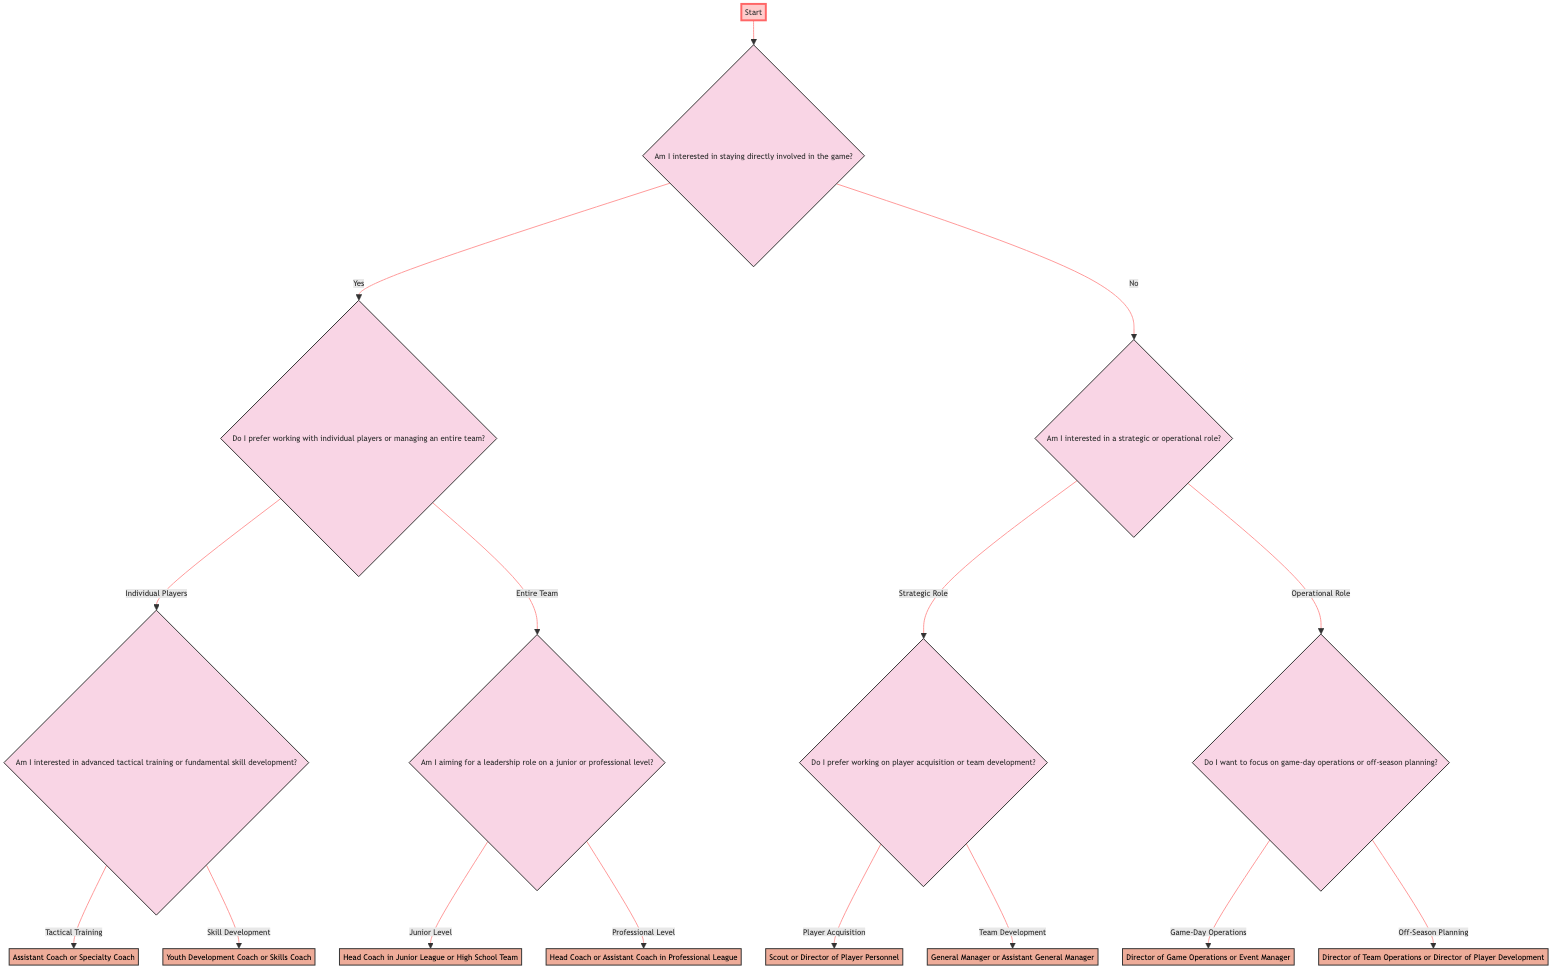What is the first question in the diagram? The first question in the diagram is found at the starting node, which is the decision about staying directly involved in the game.
Answer: Am I interested in staying directly involved in the game? How many options are there after the first question? Once the first question is asked, there are two options presented: 'Yes' or 'No'. This means there are two branches to follow based on the decision made.
Answer: 2 If the answer is "Yes", what is the next question? If the answer to the first question is "Yes", the next question is about whether the individual prefers working with individual players or managing an entire team.
Answer: Do I prefer working with individual players or managing an entire team? If I choose "Entire Team" and then "Professional Level," what should I consider pursuing? By choosing "Entire Team" and "Professional Level," the path leads directly to the decision node that suggests pursuing Head Coach or Assistant Coach in Professional League.
Answer: Head Coach or Assistant Coach in Professional League What role is suggested if the answer is "No" to staying directly involved and "Strategic Role" is chosen? If "No" is selected for staying directly involved and "Strategic Role" is chosen, the next question asks about preferences between player acquisition or team development, which leads to specific roles based on those choices.
Answer: Scout or Director of Player Personnel or General Manager or Assistant General Manager Which decision leads to a focus on off-season planning? The decision that leads to a focus on off-season planning comes from selecting "No" for staying directly involved, then selecting "Operational Role," and finally choosing "Off-Season Planning."
Answer: Director of Team Operations or Director of Player Development What is the outcome if the answer to the third question is "Tactical Training"? If "Tactical Training" is the answer to the third question about working with individual players, the outcome shows that one should consider pursuing an Assistant Coach or Specialty Coach role, specifically focusing on tactical training.
Answer: Assistant Coach or Specialty Coach How many total decision nodes are in the diagram? To find the total decision nodes, we can count them: there are six decision nodes throughout the diagram, indicating different choices at various points.
Answer: 6 If I am interested in working on player acquisition, what opportunity should I consider? If the individual is interested in player acquisition, they will reach a decision node suggesting they consider pursuing a role as a Scout or Director of Player Personnel based on that choice.
Answer: Scout or Director of Player Personnel 